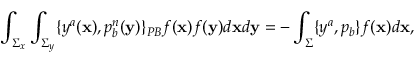<formula> <loc_0><loc_0><loc_500><loc_500>\int _ { \Sigma _ { x } } \int _ { \Sigma _ { y } } \{ y ^ { a } ( { x } ) , p _ { b } ^ { n } ( { y } ) \} _ { P B } f ( { x } ) f ( { y } ) d { x } d { y } = - \int _ { \Sigma } \{ y ^ { a } , p _ { b } \} f ( { x } ) d { x } ,</formula> 